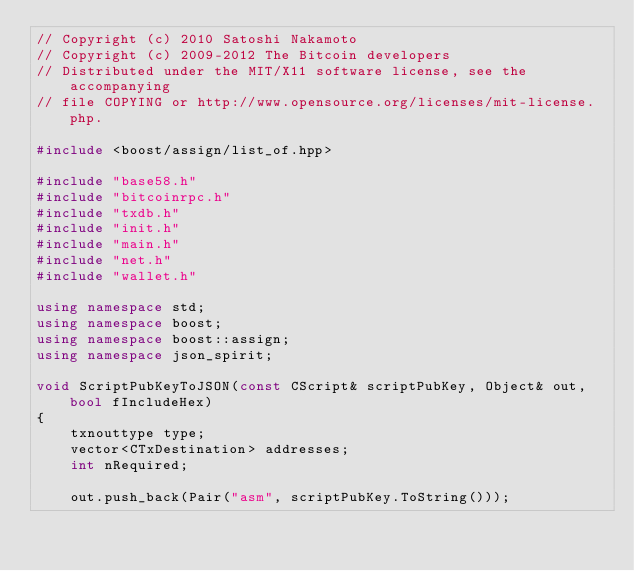Convert code to text. <code><loc_0><loc_0><loc_500><loc_500><_C++_>// Copyright (c) 2010 Satoshi Nakamoto
// Copyright (c) 2009-2012 The Bitcoin developers
// Distributed under the MIT/X11 software license, see the accompanying
// file COPYING or http://www.opensource.org/licenses/mit-license.php.

#include <boost/assign/list_of.hpp>

#include "base58.h"
#include "bitcoinrpc.h"
#include "txdb.h"
#include "init.h"
#include "main.h"
#include "net.h"
#include "wallet.h"

using namespace std;
using namespace boost;
using namespace boost::assign;
using namespace json_spirit;

void ScriptPubKeyToJSON(const CScript& scriptPubKey, Object& out, bool fIncludeHex)
{
    txnouttype type;
    vector<CTxDestination> addresses;
    int nRequired;

    out.push_back(Pair("asm", scriptPubKey.ToString()));
</code> 